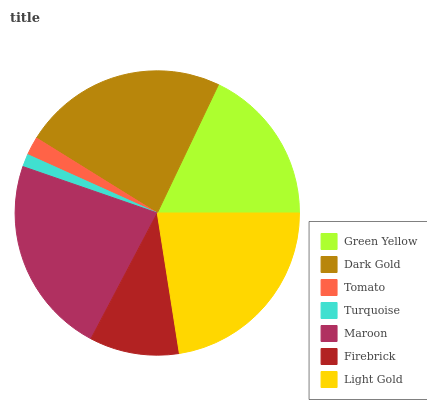Is Turquoise the minimum?
Answer yes or no. Yes. Is Dark Gold the maximum?
Answer yes or no. Yes. Is Tomato the minimum?
Answer yes or no. No. Is Tomato the maximum?
Answer yes or no. No. Is Dark Gold greater than Tomato?
Answer yes or no. Yes. Is Tomato less than Dark Gold?
Answer yes or no. Yes. Is Tomato greater than Dark Gold?
Answer yes or no. No. Is Dark Gold less than Tomato?
Answer yes or no. No. Is Green Yellow the high median?
Answer yes or no. Yes. Is Green Yellow the low median?
Answer yes or no. Yes. Is Tomato the high median?
Answer yes or no. No. Is Dark Gold the low median?
Answer yes or no. No. 